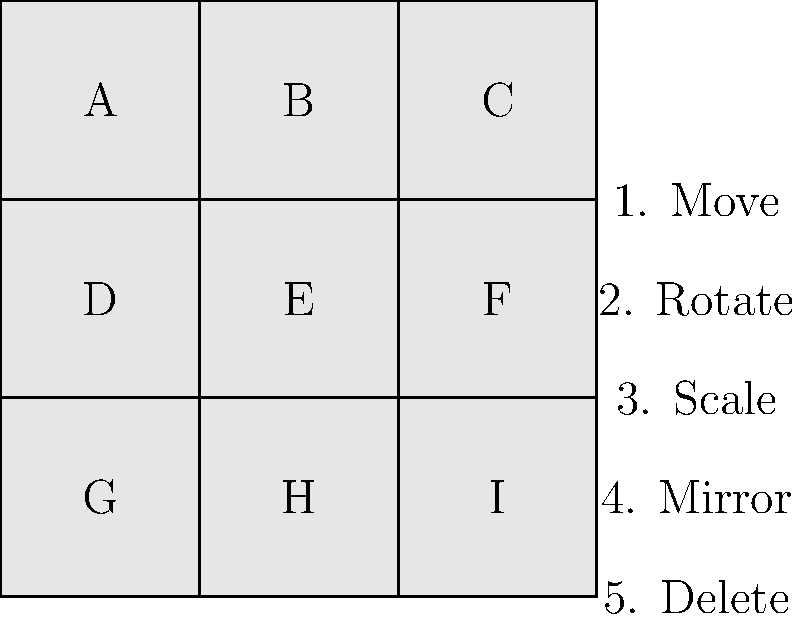Which icon in the SheetCam interface represents the "Rotate" tool? To identify the correct icon for the "Rotate" tool in SheetCam, let's analyze the given image step-by-step:

1. The image shows a 3x3 grid of icons labeled A through I.
2. To the right of the grid, there's a list of tool names with corresponding numbers.
3. The "Rotate" tool is listed as number 2 in this list.
4. In SheetCam and many other CAD programs, the rotate tool is often represented by a circular arrow or a shape with a curved arrow around it.
5. Looking at the icons in the grid, we can see that icon B in the top row has a circular shape that resembles a rotate symbol.
6. Given the typical representation of rotate tools and the position of the icon, we can conclude that icon B is most likely the "Rotate" tool in SheetCam's interface.

Therefore, the correct answer is B, representing the "Rotate" tool in SheetCam.
Answer: B 